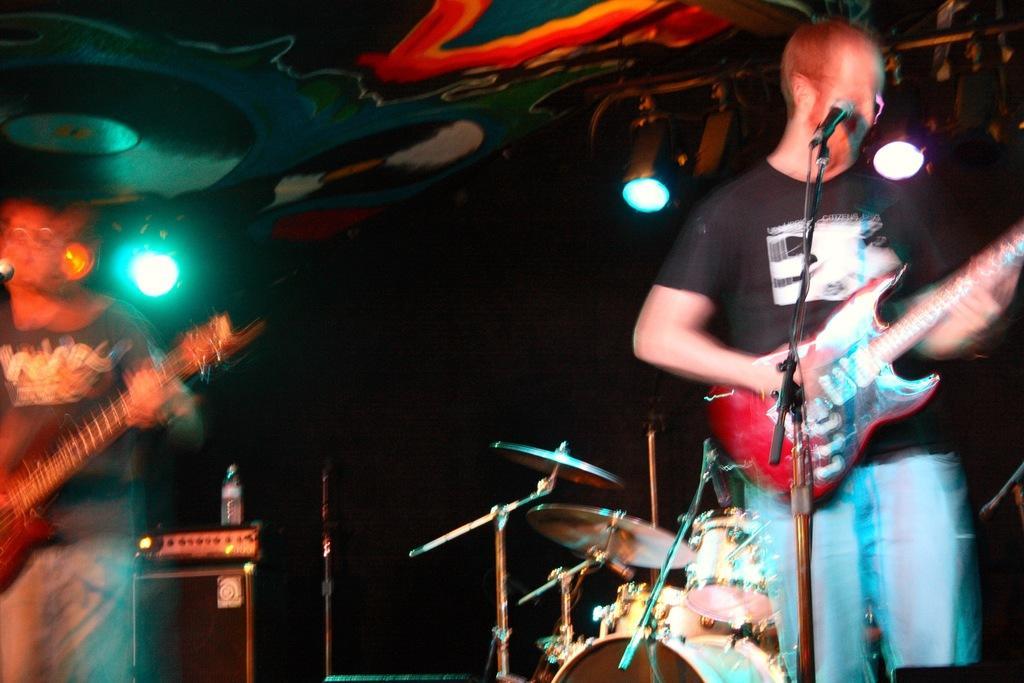How would you summarize this image in a sentence or two? There are two persons who are playing musical instruments. 